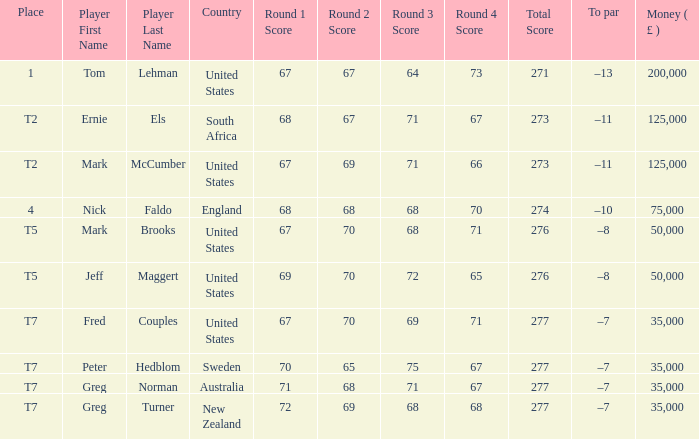What is To par, when Player is "Greg Turner"? –7. 